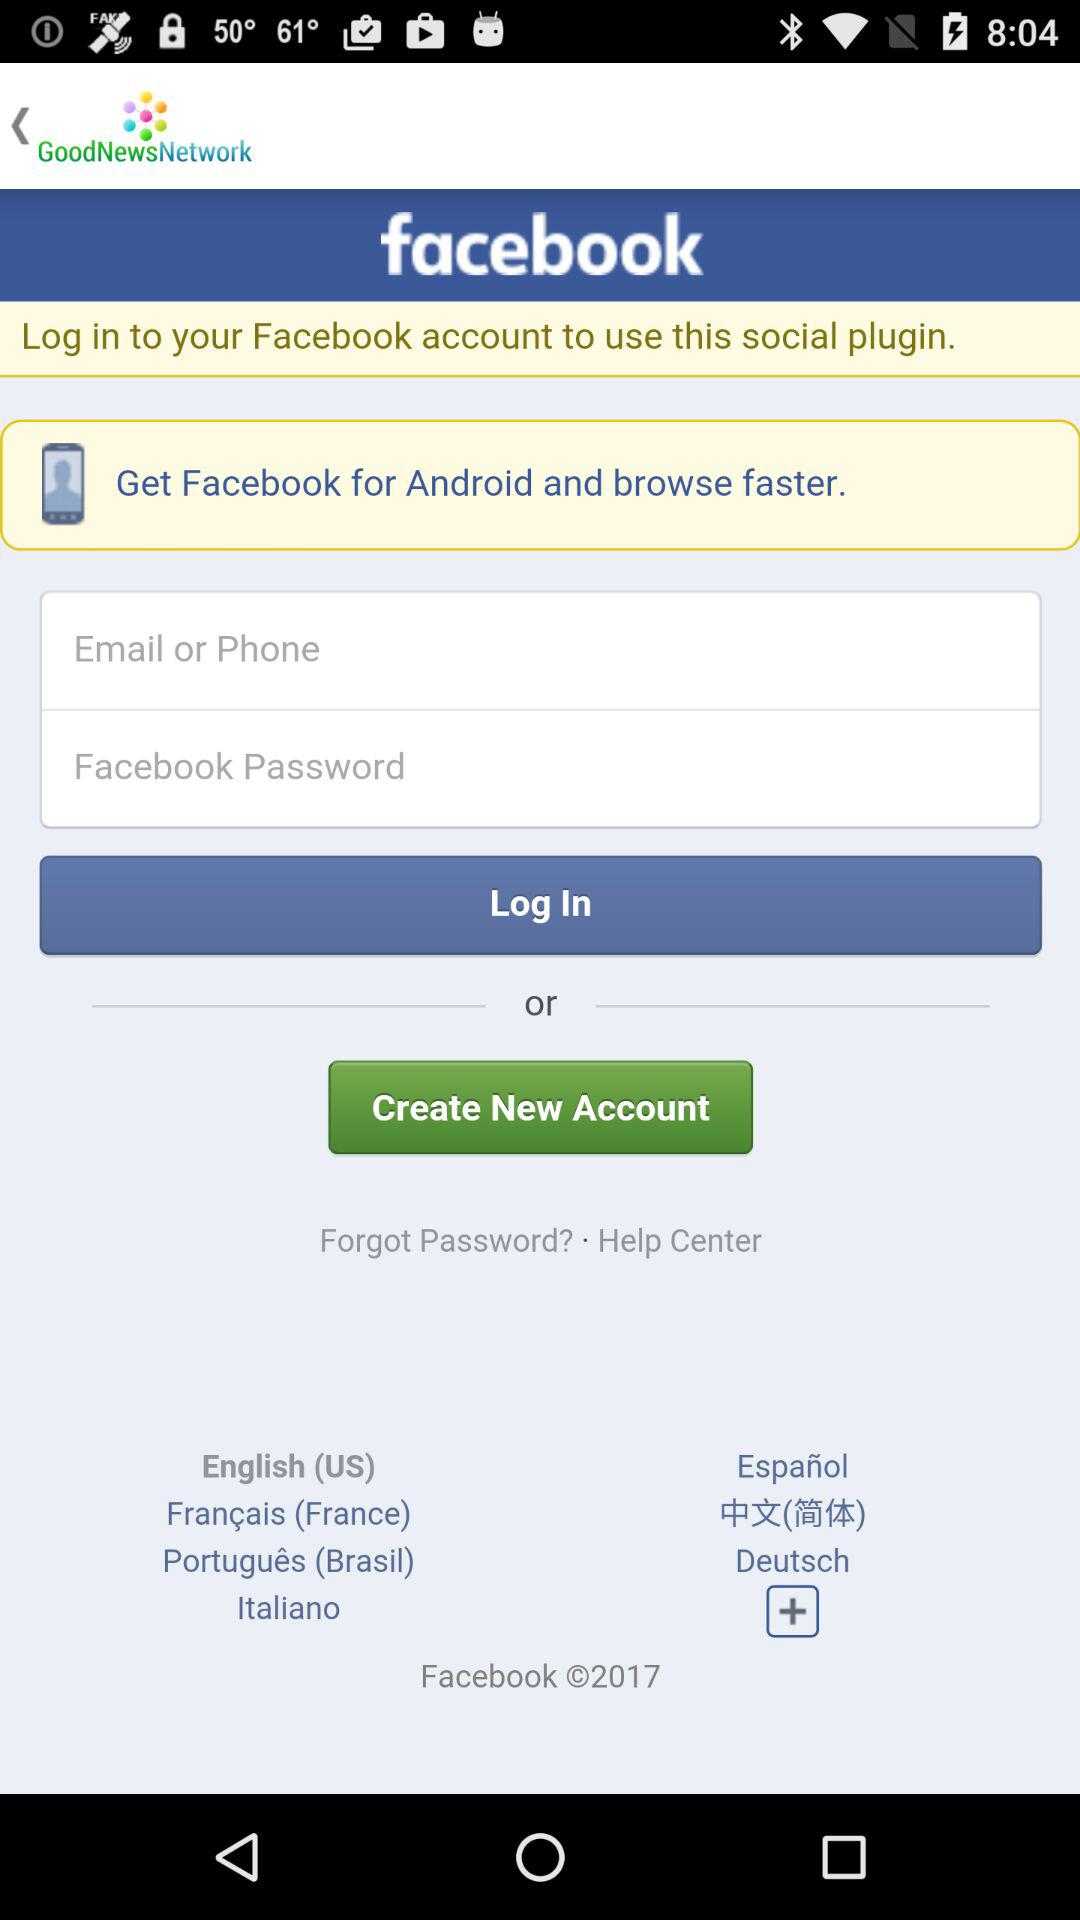How many text input fields are there on the screen?
Answer the question using a single word or phrase. 2 